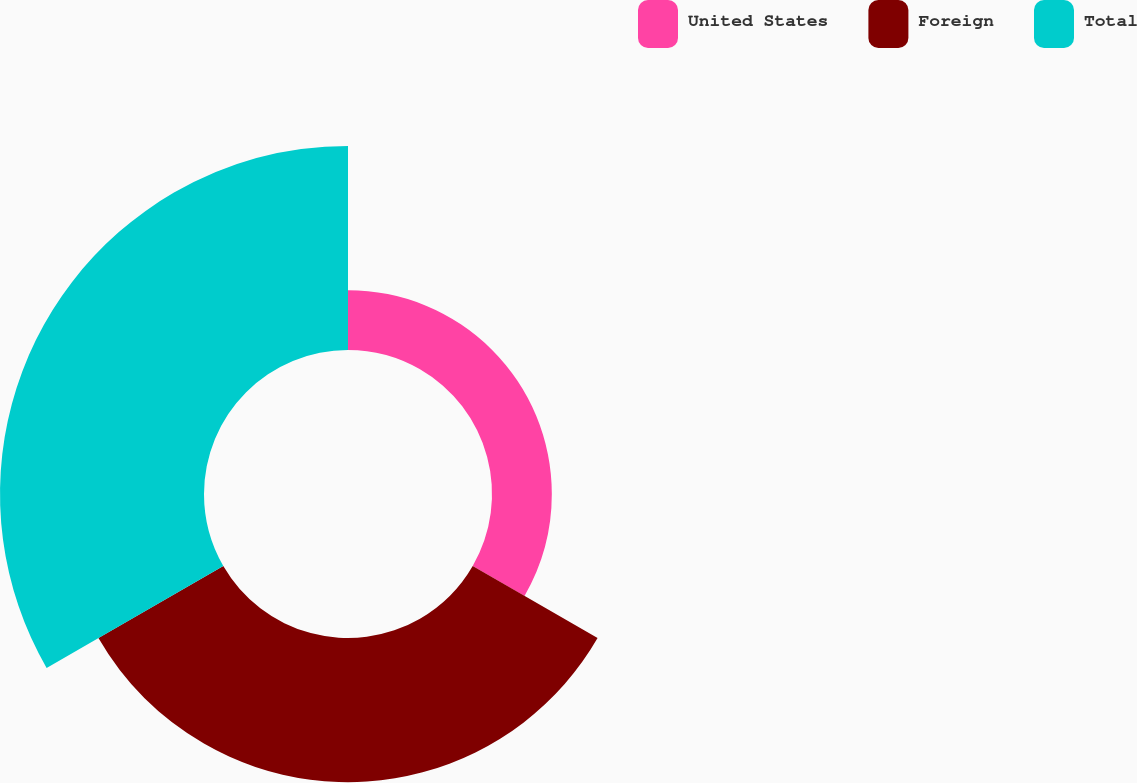Convert chart. <chart><loc_0><loc_0><loc_500><loc_500><pie_chart><fcel>United States<fcel>Foreign<fcel>Total<nl><fcel>14.66%<fcel>35.34%<fcel>50.0%<nl></chart> 